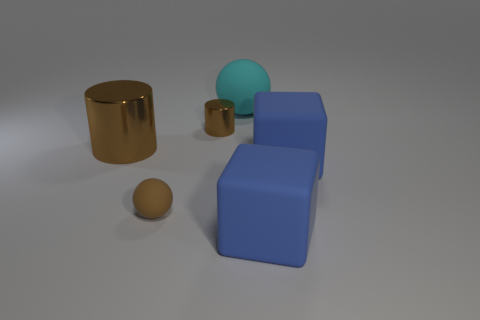Are there an equal number of big cyan things in front of the tiny brown shiny thing and brown cylinders?
Your answer should be compact. No. Is the size of the ball in front of the cyan rubber thing the same as the tiny brown metal object?
Give a very brief answer. Yes. What number of big gray matte balls are there?
Your answer should be very brief. 0. How many things are both behind the brown rubber thing and to the right of the big cyan thing?
Provide a succinct answer. 1. Are there any yellow objects made of the same material as the small brown cylinder?
Provide a succinct answer. No. There is a brown thing that is behind the big cylinder that is in front of the big sphere; what is its material?
Give a very brief answer. Metal. Is the number of big brown metal objects that are behind the cyan rubber sphere the same as the number of matte balls that are behind the big metallic cylinder?
Ensure brevity in your answer.  No. Do the large brown thing and the brown matte thing have the same shape?
Your answer should be compact. No. There is a thing that is both behind the big cylinder and in front of the cyan matte ball; what material is it?
Provide a succinct answer. Metal. How many small brown metallic things have the same shape as the large brown thing?
Provide a short and direct response. 1. 